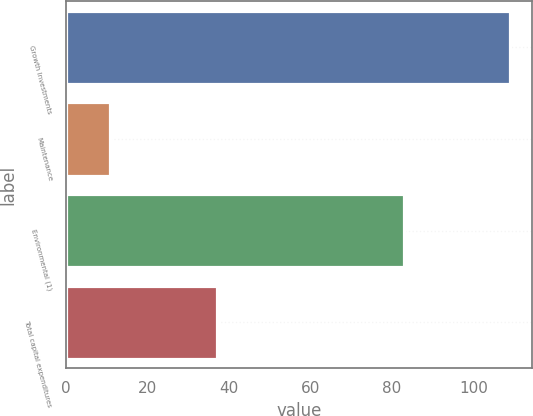<chart> <loc_0><loc_0><loc_500><loc_500><bar_chart><fcel>Growth Investments<fcel>Maintenance<fcel>Environmental (1)<fcel>Total capital expenditures<nl><fcel>109<fcel>11<fcel>83<fcel>37<nl></chart> 